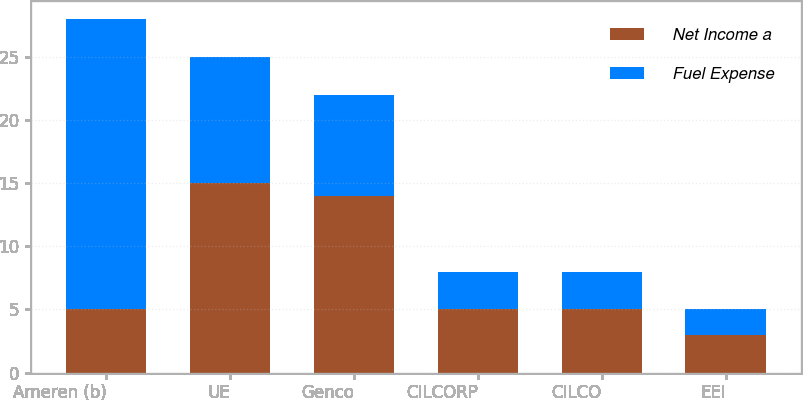Convert chart to OTSL. <chart><loc_0><loc_0><loc_500><loc_500><stacked_bar_chart><ecel><fcel>Ameren (b)<fcel>UE<fcel>Genco<fcel>CILCORP<fcel>CILCO<fcel>EEI<nl><fcel>Net Income a<fcel>5<fcel>15<fcel>14<fcel>5<fcel>5<fcel>3<nl><fcel>Fuel Expense<fcel>23<fcel>10<fcel>8<fcel>3<fcel>3<fcel>2<nl></chart> 